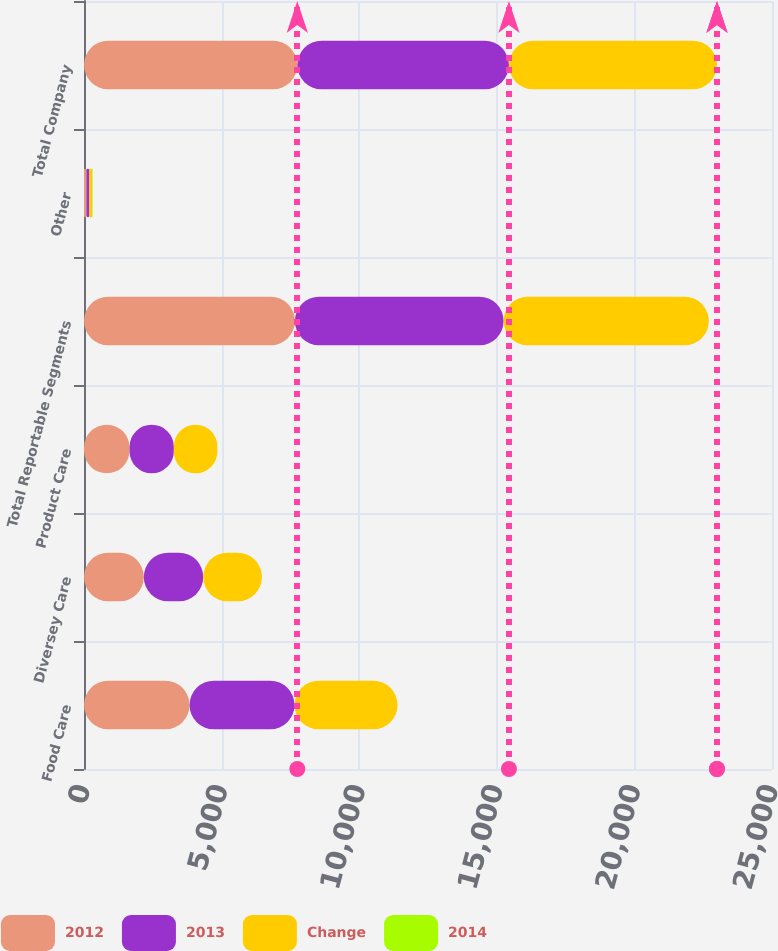<chart> <loc_0><loc_0><loc_500><loc_500><stacked_bar_chart><ecel><fcel>Food Care<fcel>Diversey Care<fcel>Product Care<fcel>Total Reportable Segments<fcel>Other<fcel>Total Company<nl><fcel>2012<fcel>3835.3<fcel>2173.1<fcel>1655<fcel>7663.4<fcel>87.1<fcel>7750.5<nl><fcel>2013<fcel>3814.2<fcel>2160.8<fcel>1610<fcel>7585<fcel>105.8<fcel>7690.8<nl><fcel>Change<fcel>3744<fcel>2131.9<fcel>1580.4<fcel>7456.3<fcel>102.9<fcel>7559.2<nl><fcel>2014<fcel>0.6<fcel>0.6<fcel>2.8<fcel>1<fcel>17.7<fcel>0.8<nl></chart> 